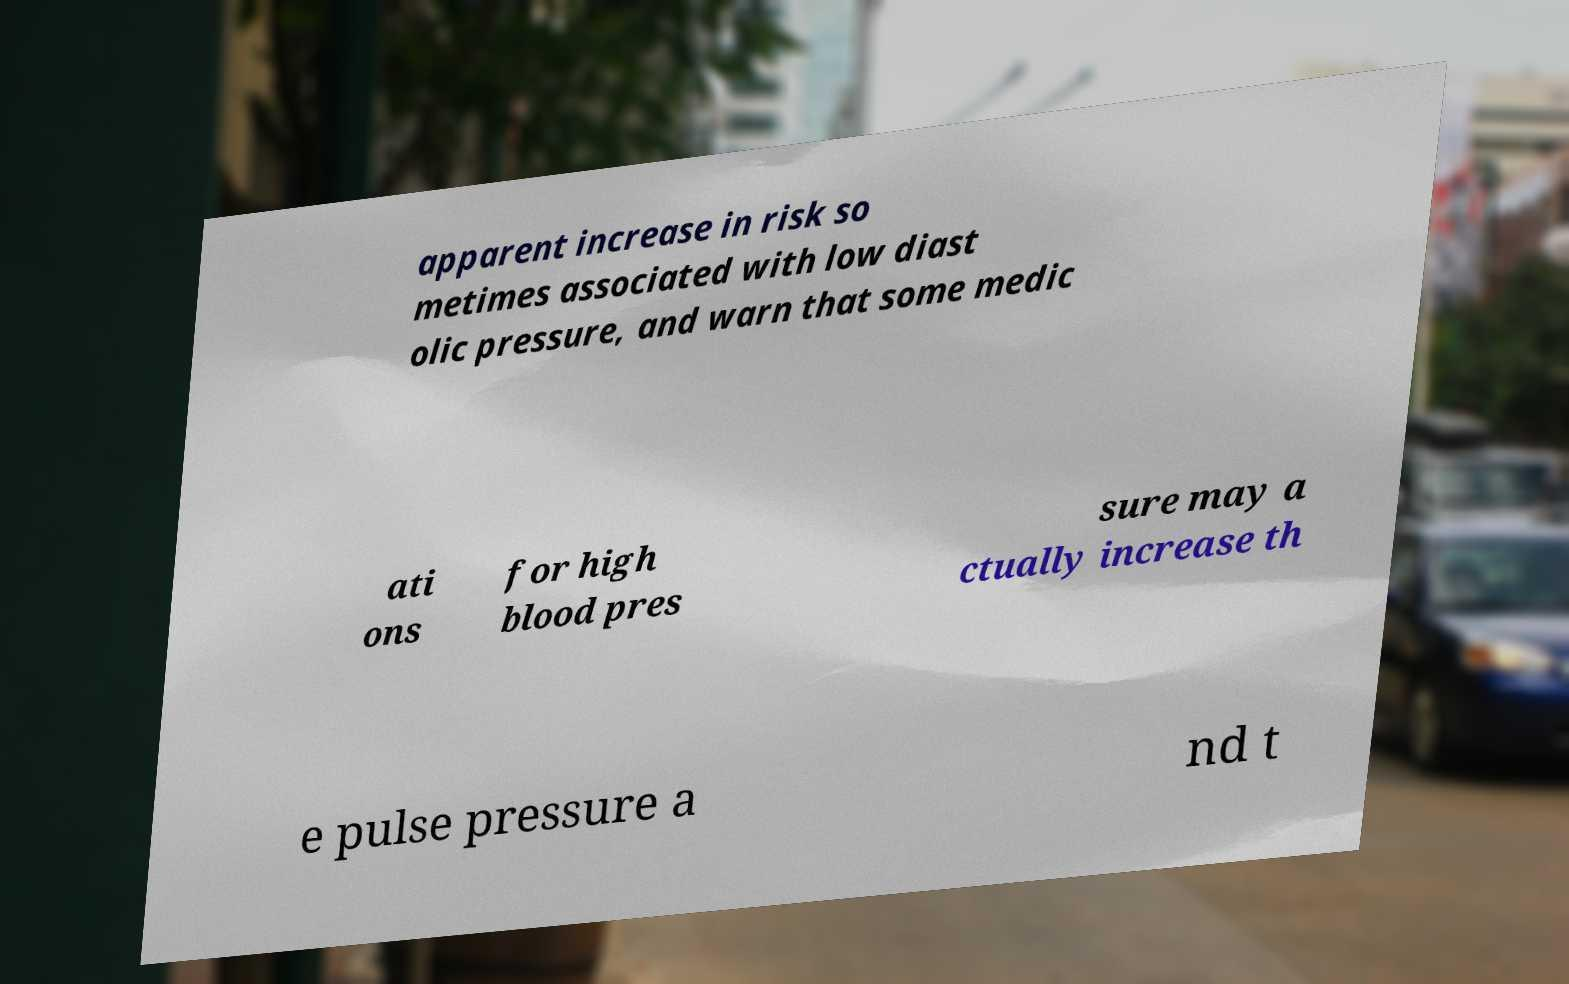I need the written content from this picture converted into text. Can you do that? apparent increase in risk so metimes associated with low diast olic pressure, and warn that some medic ati ons for high blood pres sure may a ctually increase th e pulse pressure a nd t 